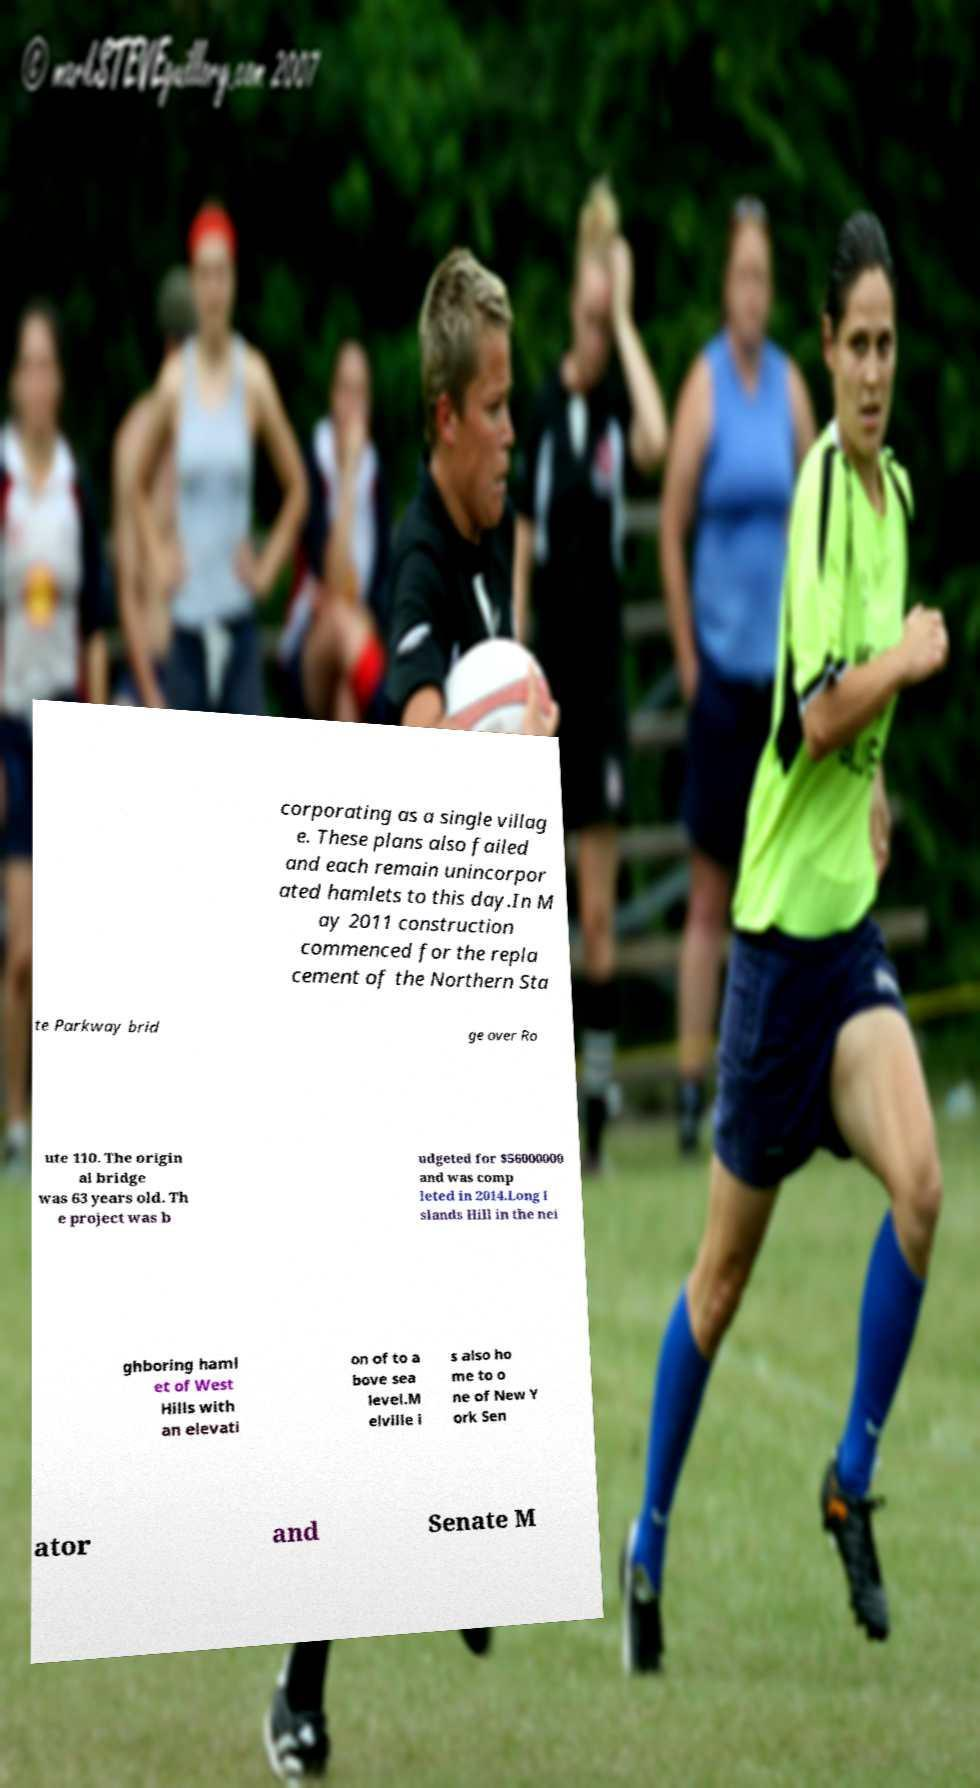Could you assist in decoding the text presented in this image and type it out clearly? corporating as a single villag e. These plans also failed and each remain unincorpor ated hamlets to this day.In M ay 2011 construction commenced for the repla cement of the Northern Sta te Parkway brid ge over Ro ute 110. The origin al bridge was 63 years old. Th e project was b udgeted for $56000000 and was comp leted in 2014.Long I slands Hill in the nei ghboring haml et of West Hills with an elevati on of to a bove sea level.M elville i s also ho me to o ne of New Y ork Sen ator and Senate M 